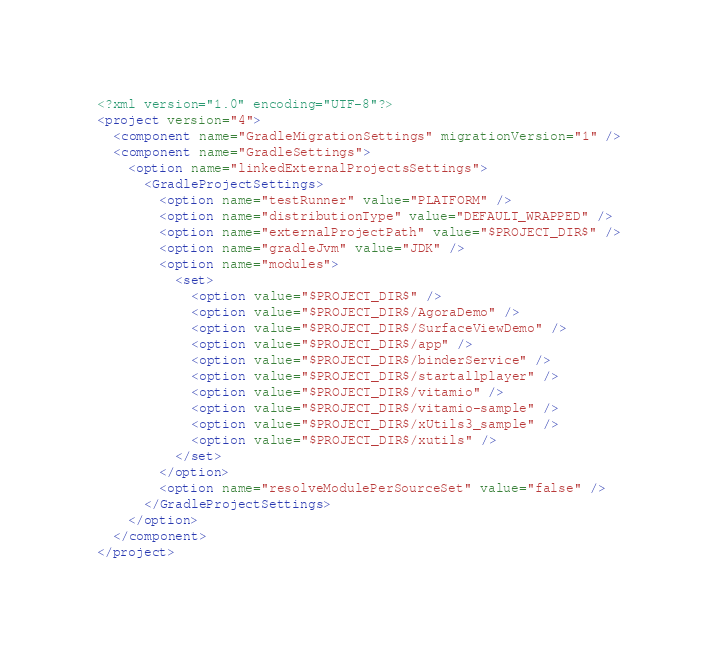<code> <loc_0><loc_0><loc_500><loc_500><_XML_><?xml version="1.0" encoding="UTF-8"?>
<project version="4">
  <component name="GradleMigrationSettings" migrationVersion="1" />
  <component name="GradleSettings">
    <option name="linkedExternalProjectsSettings">
      <GradleProjectSettings>
        <option name="testRunner" value="PLATFORM" />
        <option name="distributionType" value="DEFAULT_WRAPPED" />
        <option name="externalProjectPath" value="$PROJECT_DIR$" />
        <option name="gradleJvm" value="JDK" />
        <option name="modules">
          <set>
            <option value="$PROJECT_DIR$" />
            <option value="$PROJECT_DIR$/AgoraDemo" />
            <option value="$PROJECT_DIR$/SurfaceViewDemo" />
            <option value="$PROJECT_DIR$/app" />
            <option value="$PROJECT_DIR$/binderService" />
            <option value="$PROJECT_DIR$/startallplayer" />
            <option value="$PROJECT_DIR$/vitamio" />
            <option value="$PROJECT_DIR$/vitamio-sample" />
            <option value="$PROJECT_DIR$/xUtils3_sample" />
            <option value="$PROJECT_DIR$/xutils" />
          </set>
        </option>
        <option name="resolveModulePerSourceSet" value="false" />
      </GradleProjectSettings>
    </option>
  </component>
</project></code> 